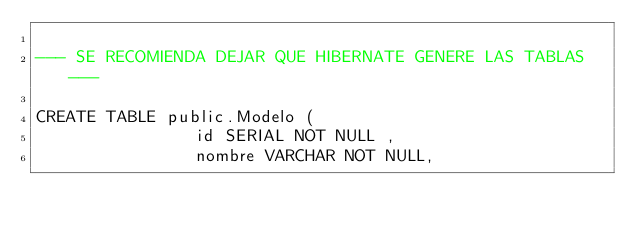<code> <loc_0><loc_0><loc_500><loc_500><_SQL_>
--- SE RECOMIENDA DEJAR QUE HIBERNATE GENERE LAS TABLAS ---

CREATE TABLE public.Modelo (
                id SERIAL NOT NULL ,
                nombre VARCHAR NOT NULL,</code> 